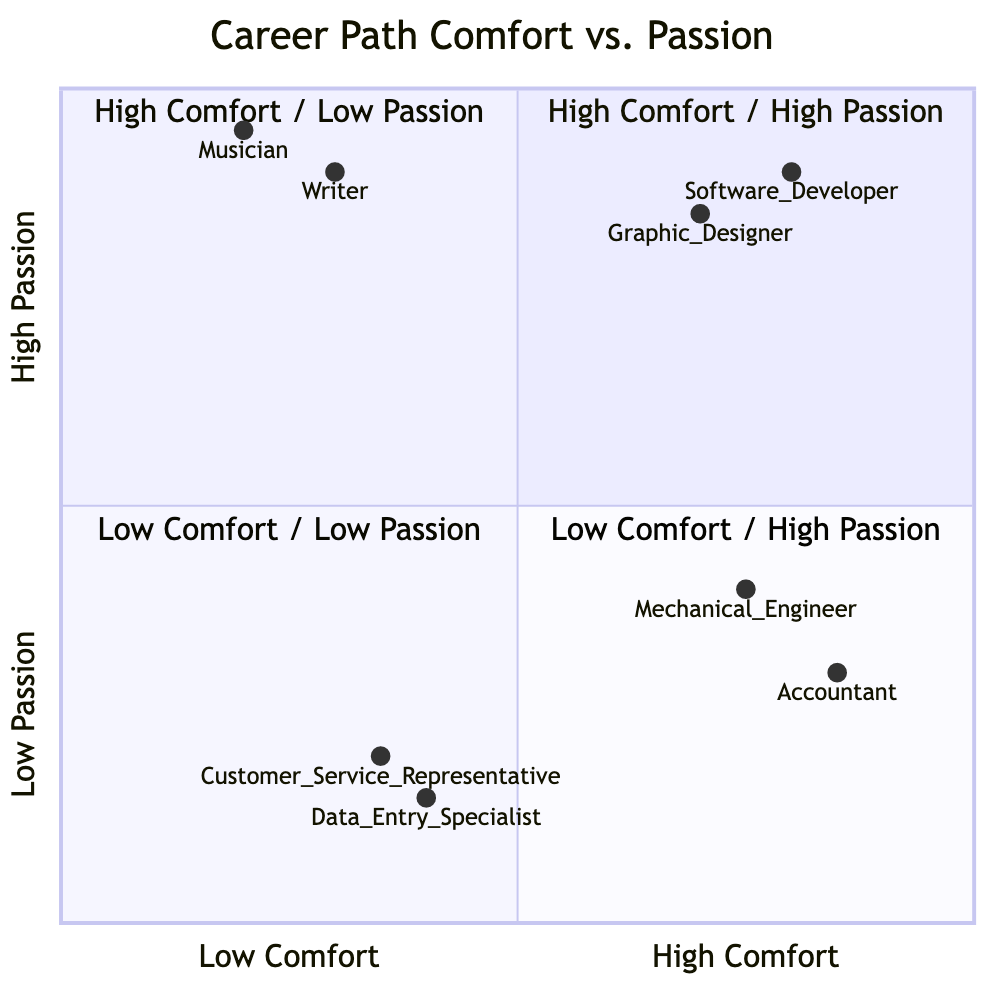What career has high comfort and high passion? Looking at the quadrant labeled "High Comfort / High Passion," the careers listed are Software Developer and Graphic Designer. Both of these careers fit the criteria defined by this quadrant.
Answer: Software Developer, Graphic Designer Which career has the highest comfort level? To determine the career with the highest comfort level, we observe the careers in the "High Comfort" sections: Software Developer, Graphic Designer, Accountant, and Mechanical Engineer. The career with the highest comfort, at 0.85 on the scale, is Accountant.
Answer: Accountant How many careers fall into the "Low Comfort / Low Passion" quadrant? Referring to the quadrant labeled "Low Comfort / Low Passion," the careers listed are Data Entry Specialist and Customer Service Representative. Thus, there are two careers in this quadrant.
Answer: 2 What is the passion level of a Graphic Designer? The Graph shows that a Graphic Designer has a passion level of 0.85 in the "High Comfort / High Passion" quadrant. This attribute reflects the high level of passion associated with this career.
Answer: 0.85 What are the attributes of a Musician? Under the "Low Comfort / High Passion" quadrant, the attributes listed for a Musician include Creative expression, Artistic community, and Performance opportunities. These attributes illustrate the career's focus and environment.
Answer: Creative expression, Artistic community, Performance opportunities Which career has the lowest comfort level? Assessing the comfort levels in the various quadrants, the career with the lowest comfort is a Musician, registering at 0.2 on the scale. This indicates a much lower comfort compared to careers in other quadrants.
Answer: Musician Which quadrant contains jobs associated with a high level of passion but low level of comfort? The "Low Comfort / High Passion" quadrant contains jobs that are characterized by this trait. The specific careers listed here are Musician and Writer.
Answer: Low Comfort / High Passion What career has a low level of passion but a high level of comfort? Within the "High Comfort / Low Passion" quadrant, the occupations present are Accountant and Mechanical Engineer, both of which show a low level of passion while maintaining high comfort.
Answer: Accountant, Mechanical Engineer What is the comfort level of a Customer Service Representative? The comfort level for a Customer Service Representative, according to the "Low Comfort / Low Passion" quadrant, is indicated by a score of 0.35. This reflects a relatively low comfort level for this career.
Answer: 0.35 